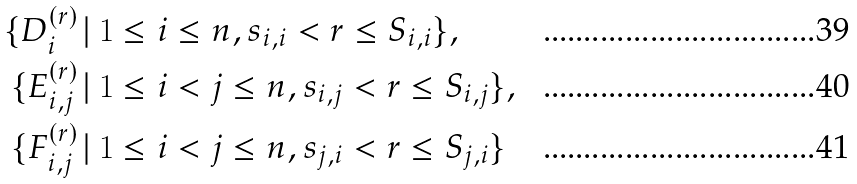<formula> <loc_0><loc_0><loc_500><loc_500>\{ D _ { i } ^ { ( r ) } \, & | \, 1 \leq i \leq n , s _ { i , i } < r \leq S _ { i , i } \} , \\ \{ E _ { i , j } ^ { ( r ) } \, & | \, 1 \leq i < j \leq n , s _ { i , j } < r \leq S _ { i , j } \} , \\ \{ F _ { i , j } ^ { ( r ) } \, & | \, 1 \leq i < j \leq n , s _ { j , i } < r \leq S _ { j , i } \}</formula> 